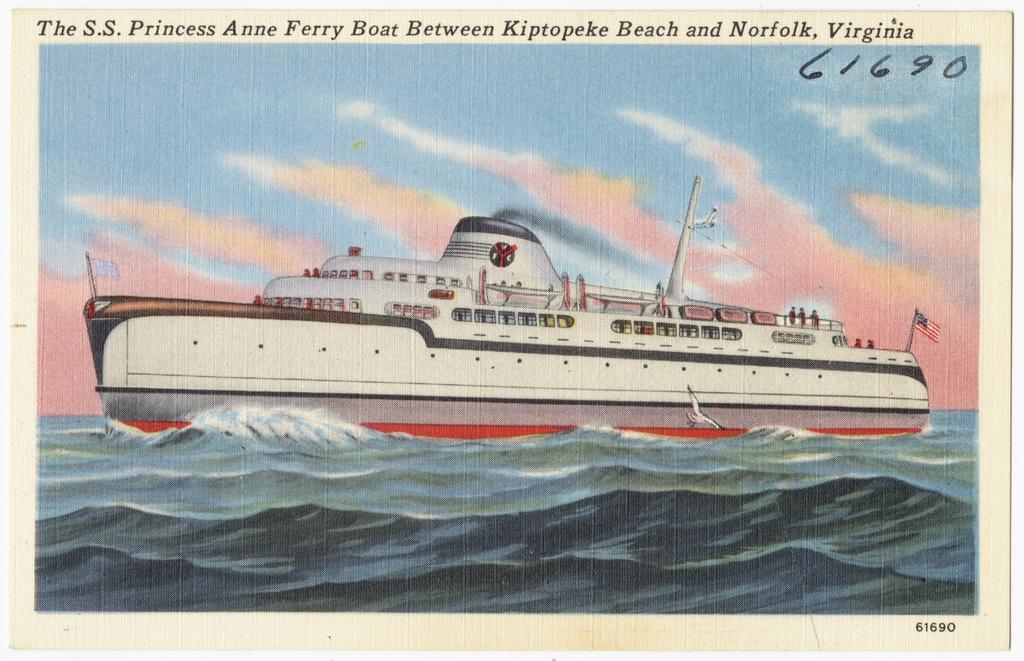In one or two sentences, can you explain what this image depicts? This is a photograph and here we can see a ship on the water and at the top, there is some text written. 